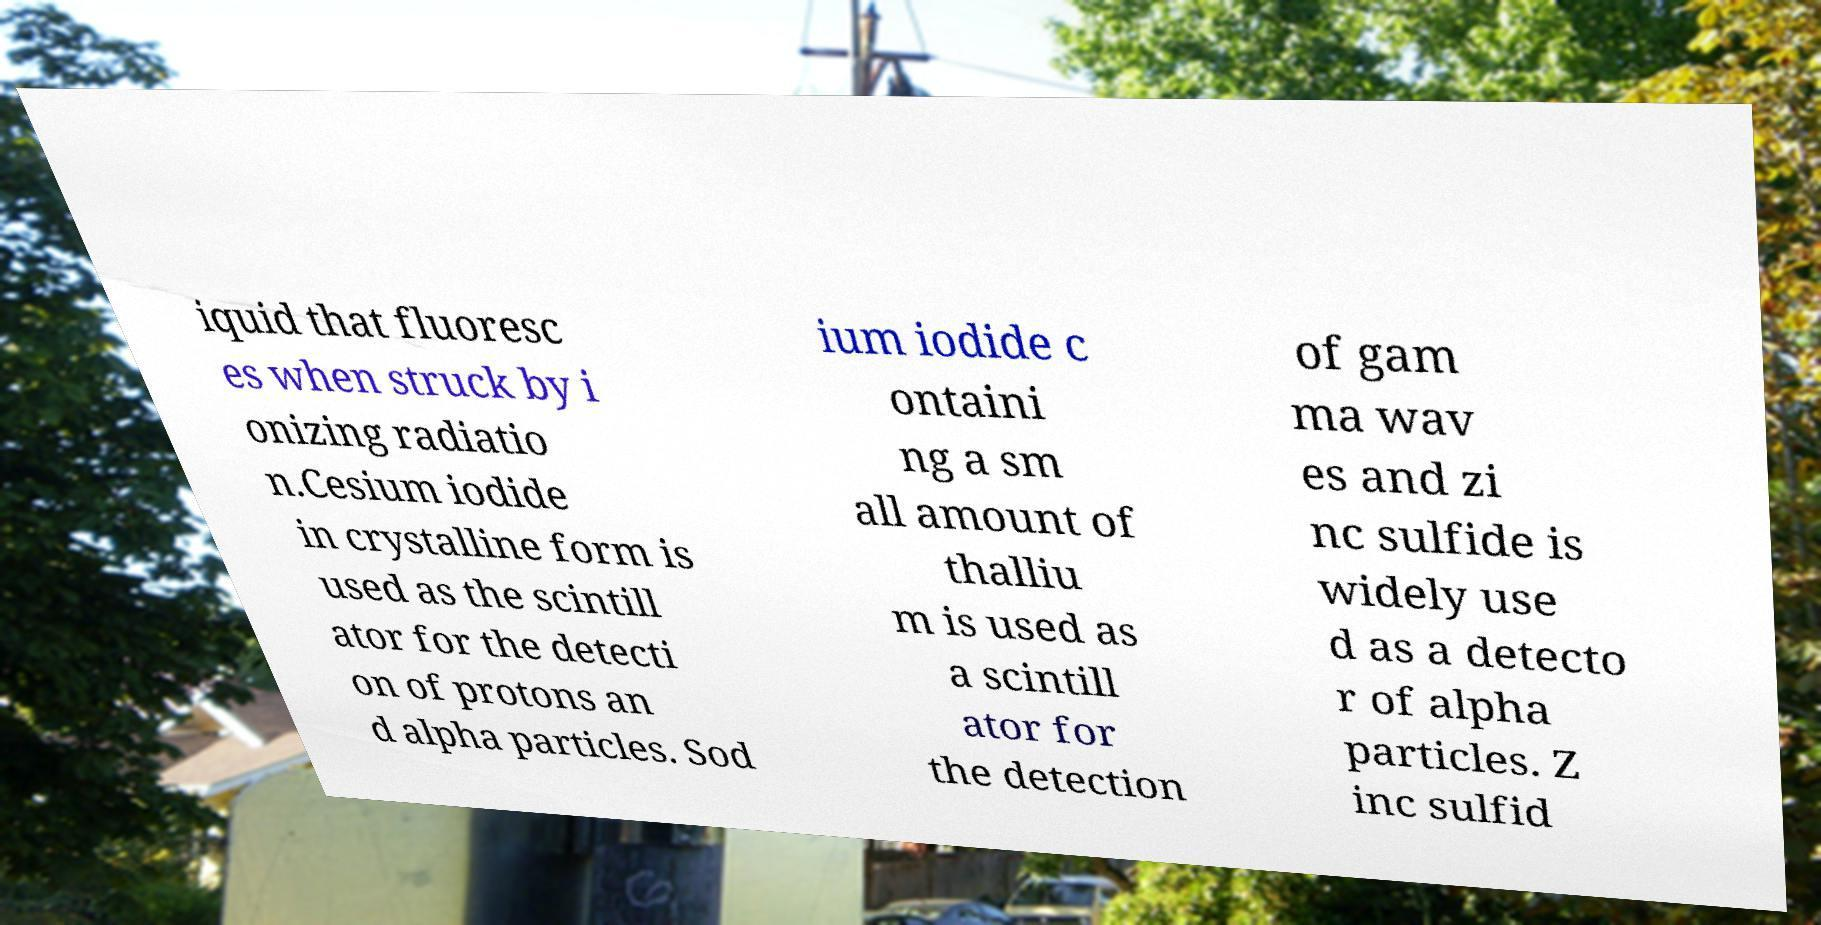There's text embedded in this image that I need extracted. Can you transcribe it verbatim? iquid that fluoresc es when struck by i onizing radiatio n.Cesium iodide in crystalline form is used as the scintill ator for the detecti on of protons an d alpha particles. Sod ium iodide c ontaini ng a sm all amount of thalliu m is used as a scintill ator for the detection of gam ma wav es and zi nc sulfide is widely use d as a detecto r of alpha particles. Z inc sulfid 